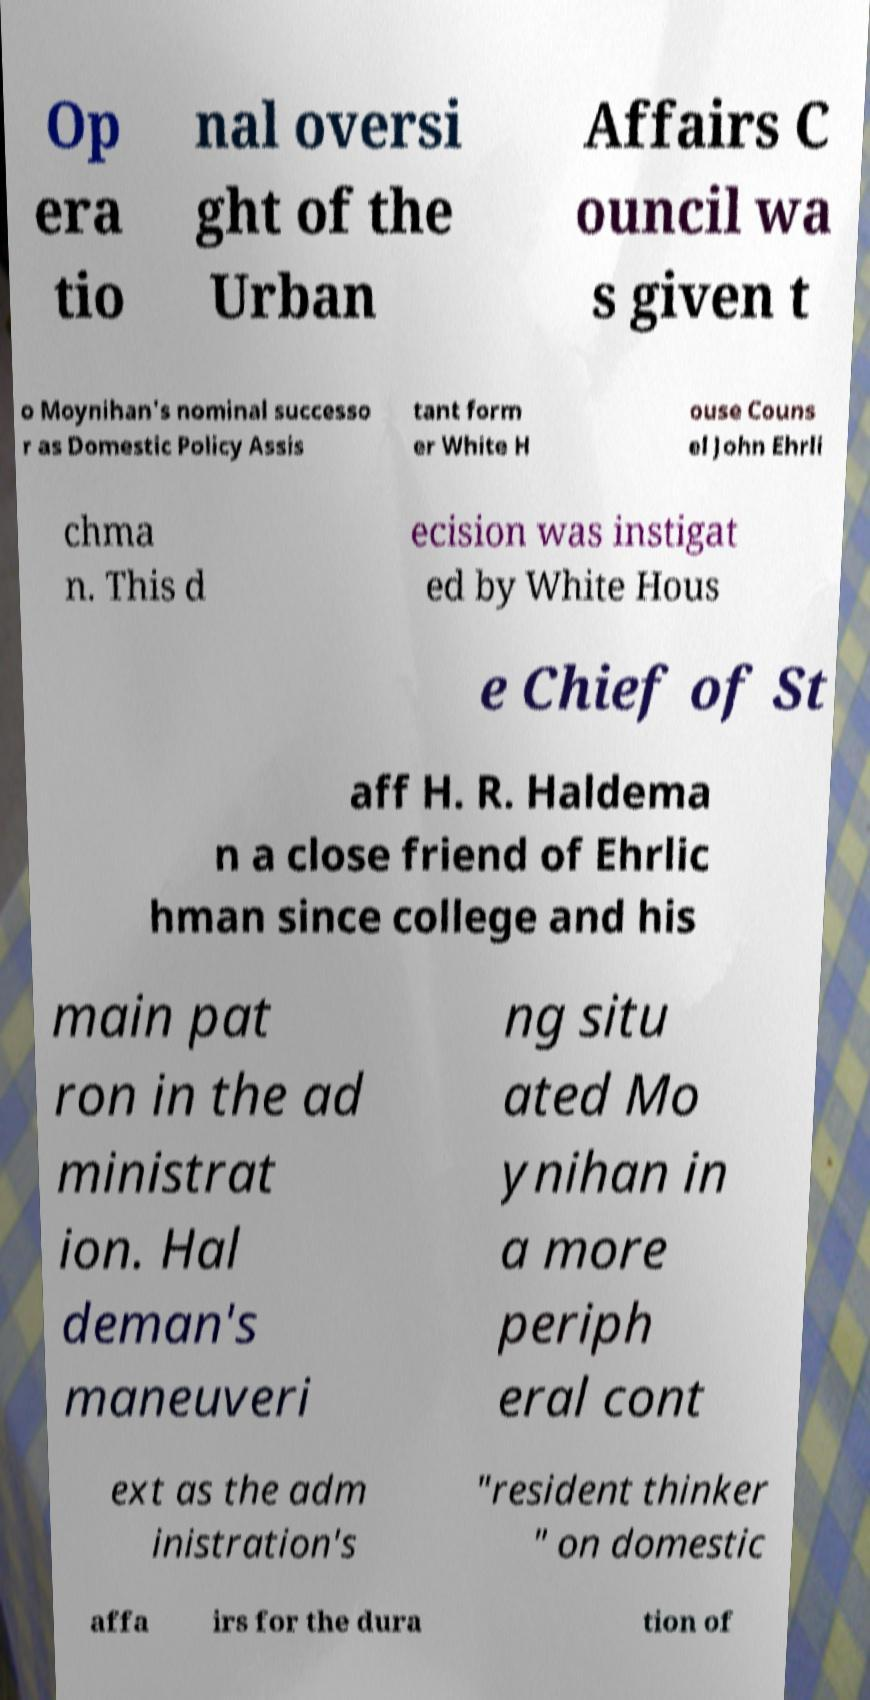Could you extract and type out the text from this image? Op era tio nal oversi ght of the Urban Affairs C ouncil wa s given t o Moynihan's nominal successo r as Domestic Policy Assis tant form er White H ouse Couns el John Ehrli chma n. This d ecision was instigat ed by White Hous e Chief of St aff H. R. Haldema n a close friend of Ehrlic hman since college and his main pat ron in the ad ministrat ion. Hal deman's maneuveri ng situ ated Mo ynihan in a more periph eral cont ext as the adm inistration's "resident thinker " on domestic affa irs for the dura tion of 